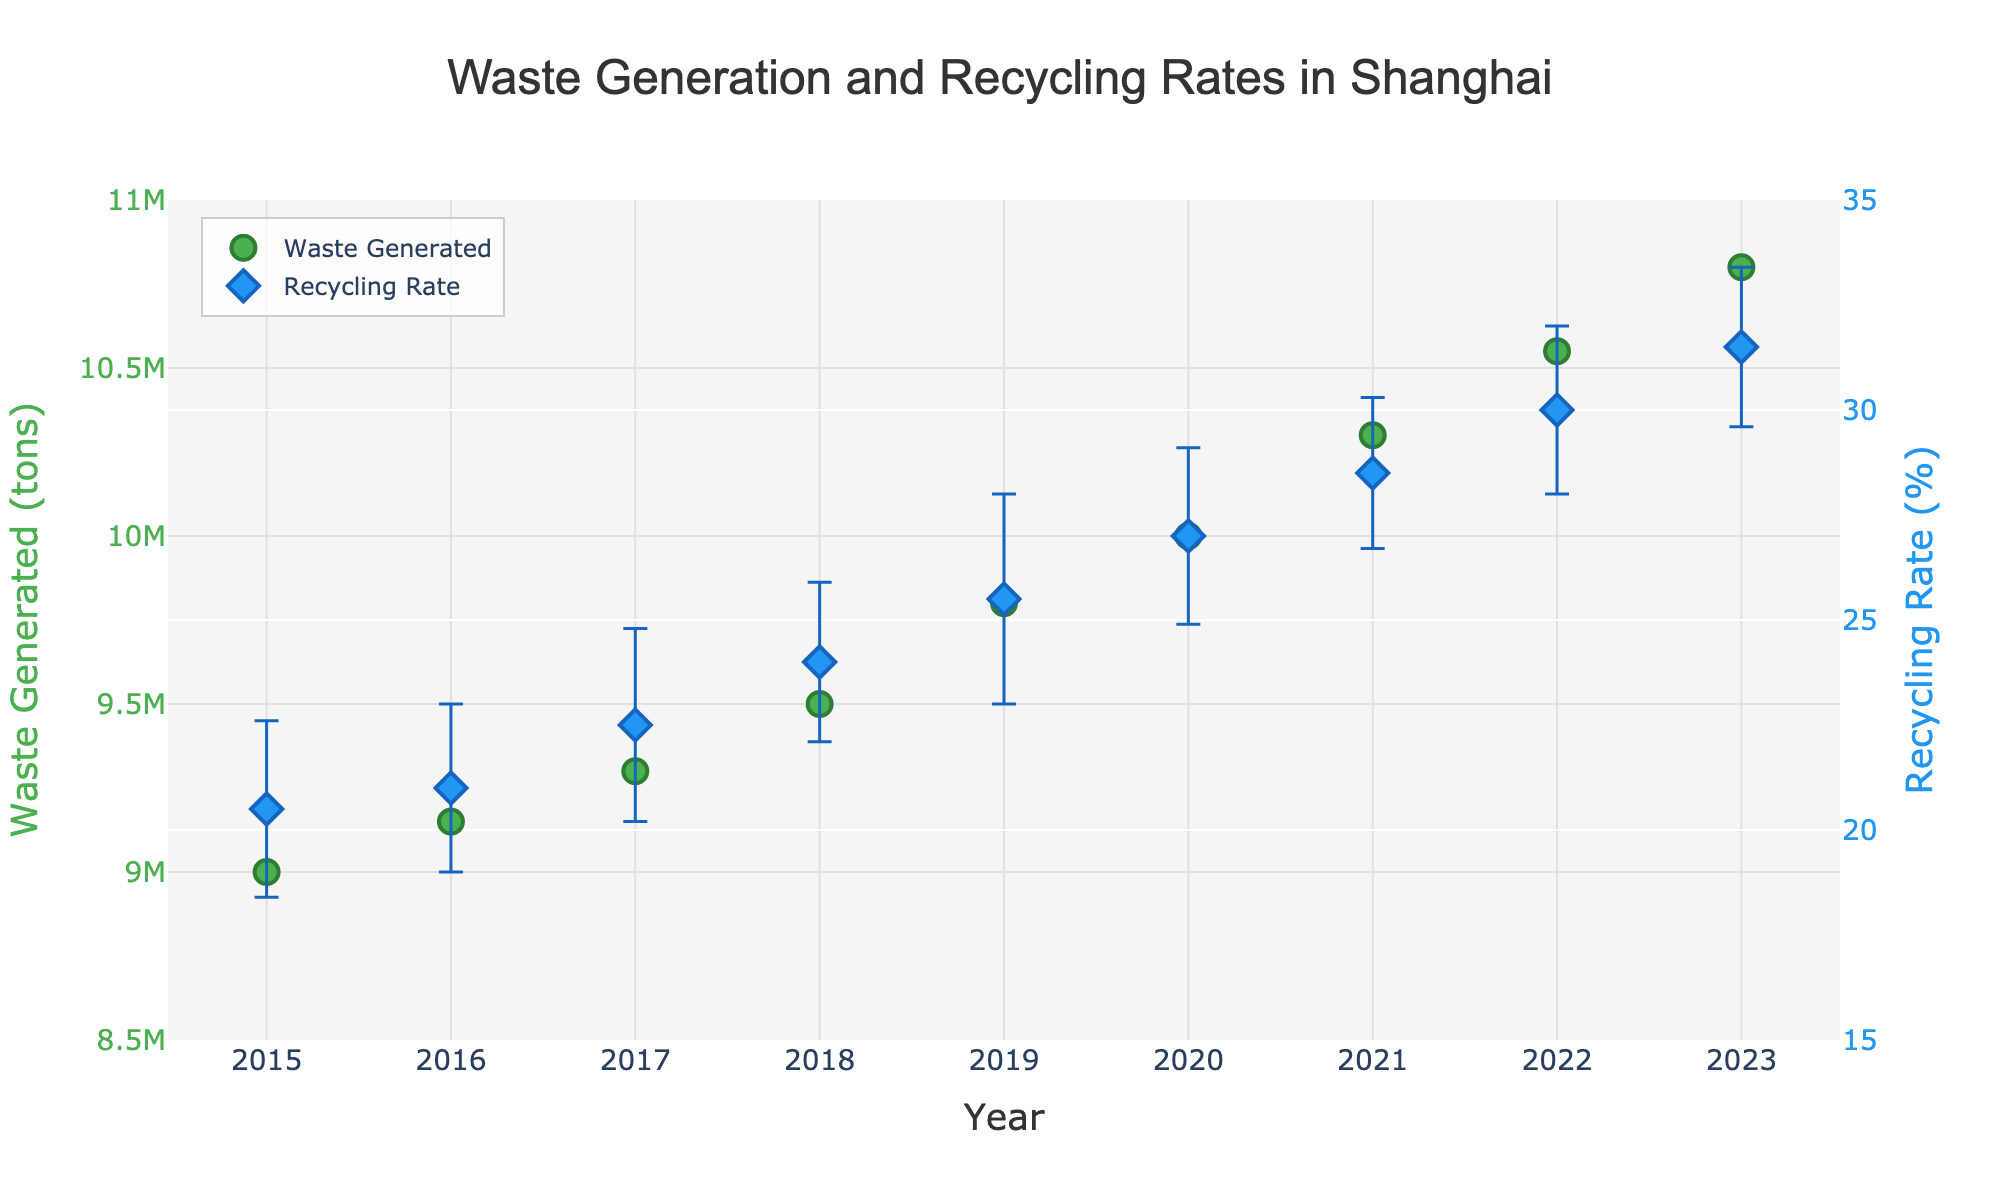What is the title of the figure? The title is displayed at the top center of the plot and reads "Waste Generation and Recycling Rates in Shanghai".
Answer: Waste Generation and Recycling Rates in Shanghai What color are the markers representing the Waste Generated data? The Waste Generated markers are green, as indicated by the visual representation in the plot.
Answer: Green In which year did the recycling rate reach 30%? The recycling rate reached 30% in 2022, as seen by locating the point along the "Year" axis corresponding to this recycling rate.
Answer: 2022 How has the waste generated changed from 2015 to 2023? By comparing the Waste Generated values for 2015 and 2023, we see an increase from 9,000,000 tons to 10,800,000 tons.
Answer: Increased by 1,800,000 tons Which year has the highest Recycling Rate? By observing the recycling rate data points, 2023 has the highest rate at 31.5%.
Answer: 2023 What is the difference in Recycling Rate between 2017 and 2019? The Recycling Rate for 2017 is 22.5%, and for 2019, it is 25.5%. The difference is 25.5% - 22.5% = 3%.
Answer: 3% What is the average Recycling Rate from 2015 to 2023? Summing up the recycling rates from 2015 to 2023: 20.5 + 21.0 + 22.5 + 24.0 + 25.5 + 27.0 + 28.5 + 30.0 + 31.5 = 230.5%. Then divide by the number of years (9), so 230.5 / 9 ≈ 25.6%.
Answer: 25.6% What is the error bar length for the Recycling Rate in 2016? The error bar for 2016 is indicated as 2.0% on the plot.
Answer: 2.0% Compare the trend of Waste Generated and Recycling Rate from 2015 to 2023. Both Waste Generated and Recycling Rate show an increasing trend over the years. Waste Generated increases steadily, while the Recycling Rate rises more sharply.
Answer: Both increased What is the smallest error bar for any Recycling Rate measurement, and in which year? The smallest error bar is 1.8%, observed in 2021.
Answer: 1.8% in 2021 